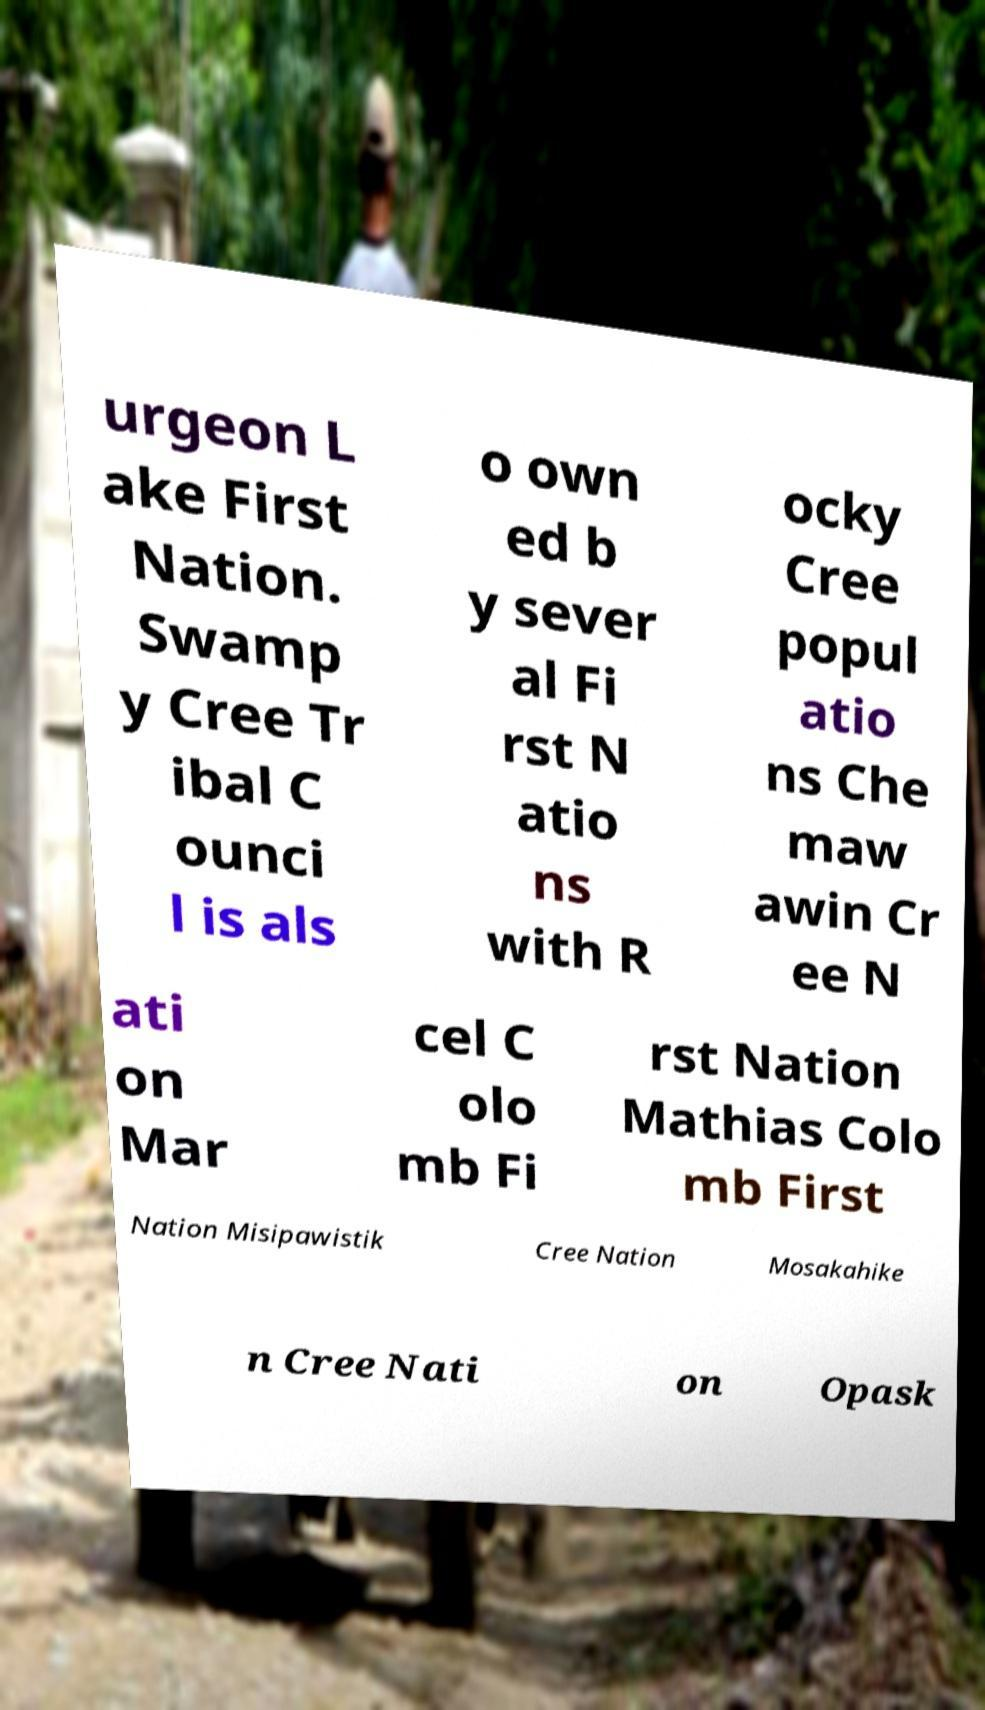Please read and relay the text visible in this image. What does it say? urgeon L ake First Nation. Swamp y Cree Tr ibal C ounci l is als o own ed b y sever al Fi rst N atio ns with R ocky Cree popul atio ns Che maw awin Cr ee N ati on Mar cel C olo mb Fi rst Nation Mathias Colo mb First Nation Misipawistik Cree Nation Mosakahike n Cree Nati on Opask 